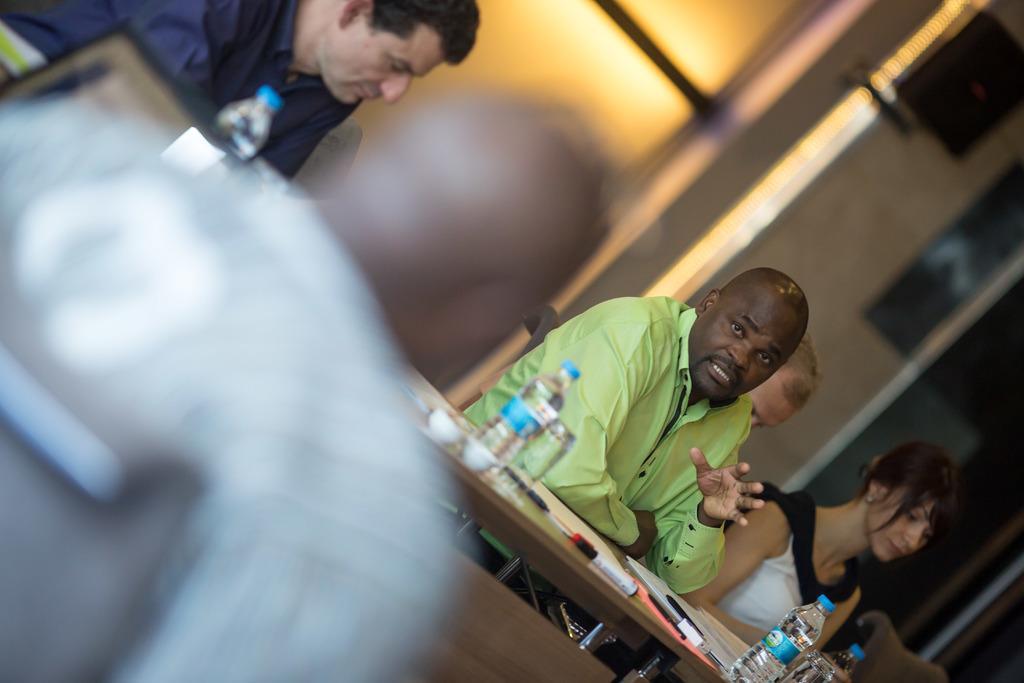How would you summarize this image in a sentence or two? Here we can see few persons are sitting on the chairs. This is a table. On the table there are bottles, glasses, cups, and papers. In the background we can see a wall. 